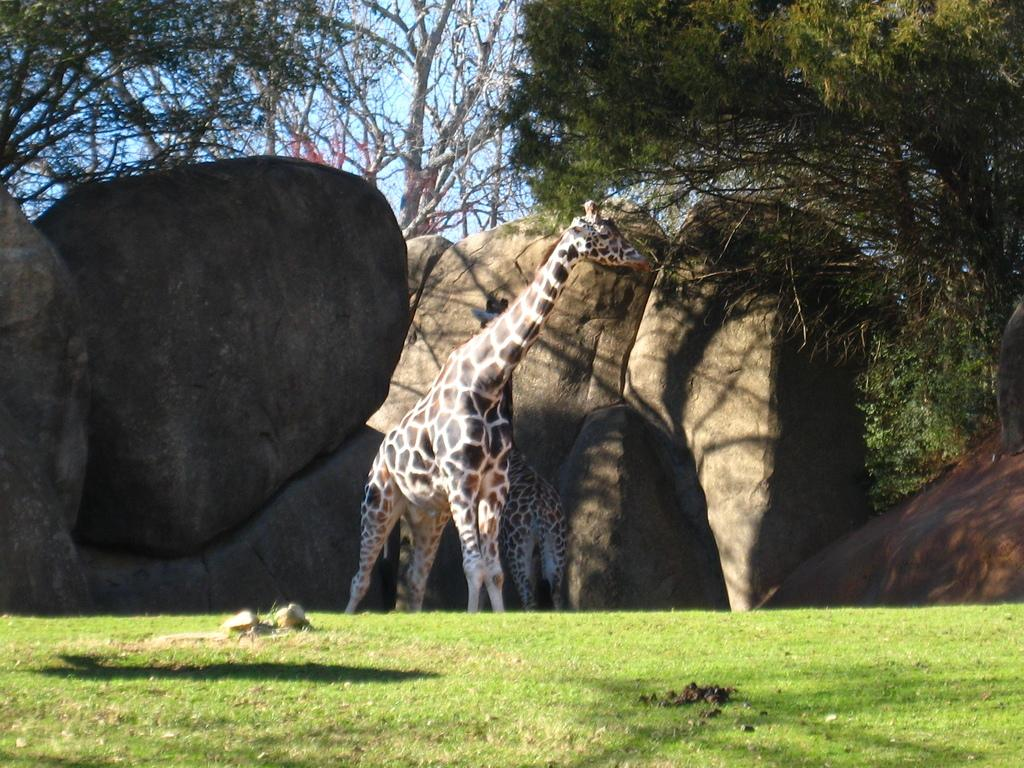What animals can be seen in the image? There are giraffes in the image. What colors are the giraffes? The giraffes have brown, cream, and black colors. What type of natural features are present in the image? There are rocks and trees in the image. What is the color of the sky in the image? The sky is blue in the image. What company is responsible for the camera used to take this image? There is no information about the camera or the company that made it in the image. 